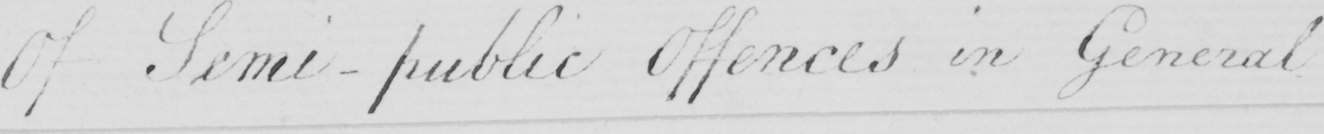What is written in this line of handwriting? Of Semi-public Offences in General . 